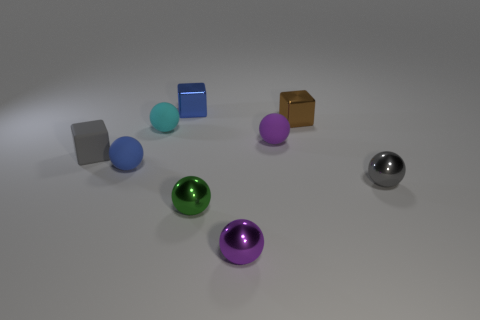Is the number of tiny blue things behind the small gray cube greater than the number of purple objects on the right side of the small brown metallic block?
Your answer should be very brief. Yes. There is a blue thing that is the same shape as the brown shiny thing; what is its size?
Ensure brevity in your answer.  Small. What number of cylinders are either big yellow things or tiny cyan things?
Keep it short and to the point. 0. What material is the sphere that is the same color as the small rubber cube?
Ensure brevity in your answer.  Metal. Are there fewer small gray shiny balls right of the brown shiny block than brown things that are in front of the cyan object?
Offer a very short reply. No. How many objects are small spheres that are behind the blue ball or small things?
Provide a succinct answer. 9. There is a small purple thing in front of the small blue object in front of the tiny rubber cube; what is its shape?
Your response must be concise. Sphere. Is there a brown cube that has the same size as the blue cube?
Provide a succinct answer. Yes. Is the number of tiny gray metallic objects greater than the number of matte balls?
Offer a terse response. No. There is a cube that is left of the tiny cyan matte ball; is its size the same as the blue object that is in front of the small cyan rubber object?
Your answer should be compact. Yes. 